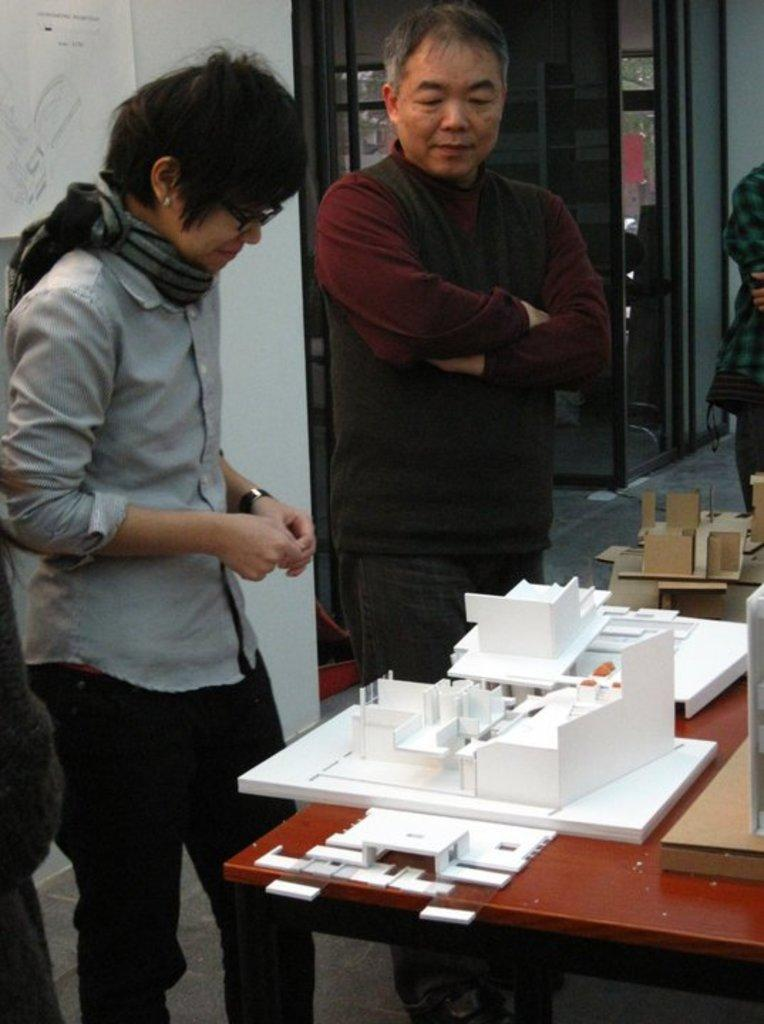How many people are in the image? There are two people in the image. What are the two people doing in the image? The two people are standing in front of a table. What can be seen on the table in the image? There are things on the table. What is visible in the background of the image? There is a door visible in the background of the image. How many hens are sitting on the books in the image? There are no hens or books present in the image. 